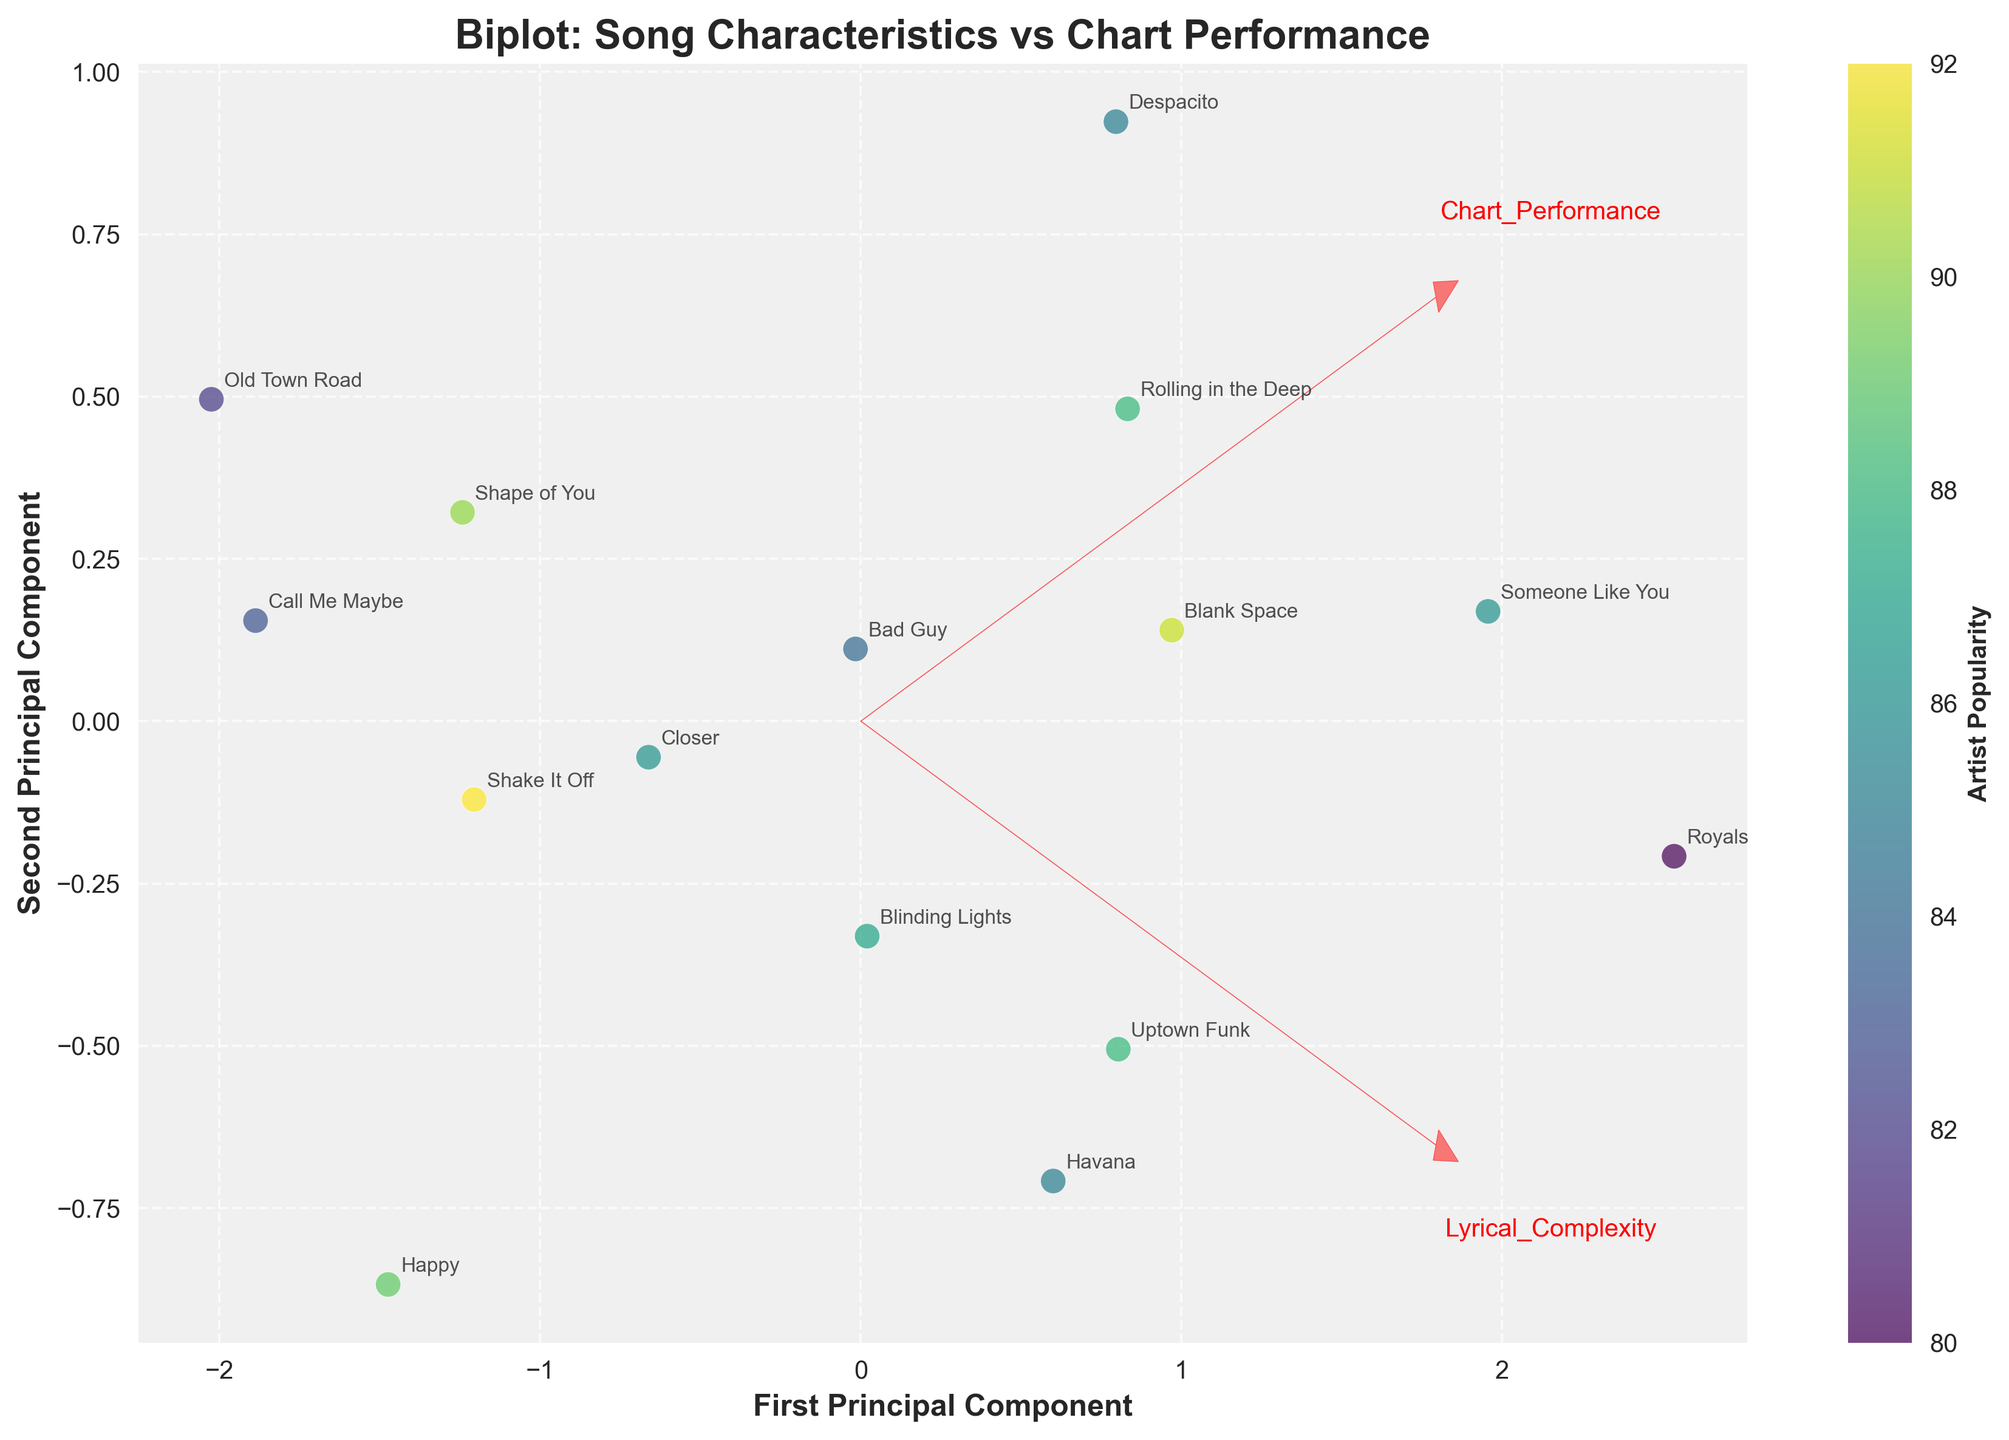What is the title of the plot? The title of the plot is often located at the top and denotes the main subject of the figure. The title in this plot reads "Biplot: Song Characteristics vs Chart Performance".
Answer: Biplot: Song Characteristics vs Chart Performance What are the labels of the axes? The axes labels are usually displayed along the horizontal and vertical axes. In this plot, they are "First Principal Component" for the x-axis and "Second Principal Component" for the y-axis.
Answer: First Principal Component and Second Principal Component How is artist popularity represented in the plot? The color of the data points, ranging from lighter to darker shades, is used to represent artist popularity, with a color bar indicating the gradient.
Answer: By color gradient on data points Which song has the highest Chart Performance? Identifying the song with the highest Chart Performance involves looking at the point that corresponds to the highest value projected in the relevant component. "Old Town Road" is displayed near maximum Chart Performance.
Answer: Old Town Road Is there a noticeable trend between Lyrical Complexity and Chart Performance? Observing the direction and magnitude of the arrows representing variables can reveal any trends. The arrows for Lyrical Complexity and Chart Performance point in similar directions, suggesting a positive relationship.
Answer: Positive relationship Which genre appears most frequently in the plot? Review the data points and songs listed in the plot to see which genre appears most often. "Pop" is the most frequently occurring genre.
Answer: Pop How are the arrows for Lyrical Complexity and Chart Performance oriented? The direction of the arrows indicates how the variables contribute to the principal components. The arrows for Lyrical Complexity and Chart Performance point to similar regions, suggesting a positive correlation.
Answer: Similar direction Which song has the lowest Lyrical Complexity? Locate the point associated with the smallest projected value in the dimension indicated by the Lyrical Complexity arrow. "Happy" has the lowest Lyrical Complexity.
Answer: Happy Which two songs are closest to each other on the plot? By measuring the visual distances between points, we can identify the closest pair. "Shape of You" and "Shake It Off" appear closest on the plot.
Answer: Shape of You and Shake It Off 